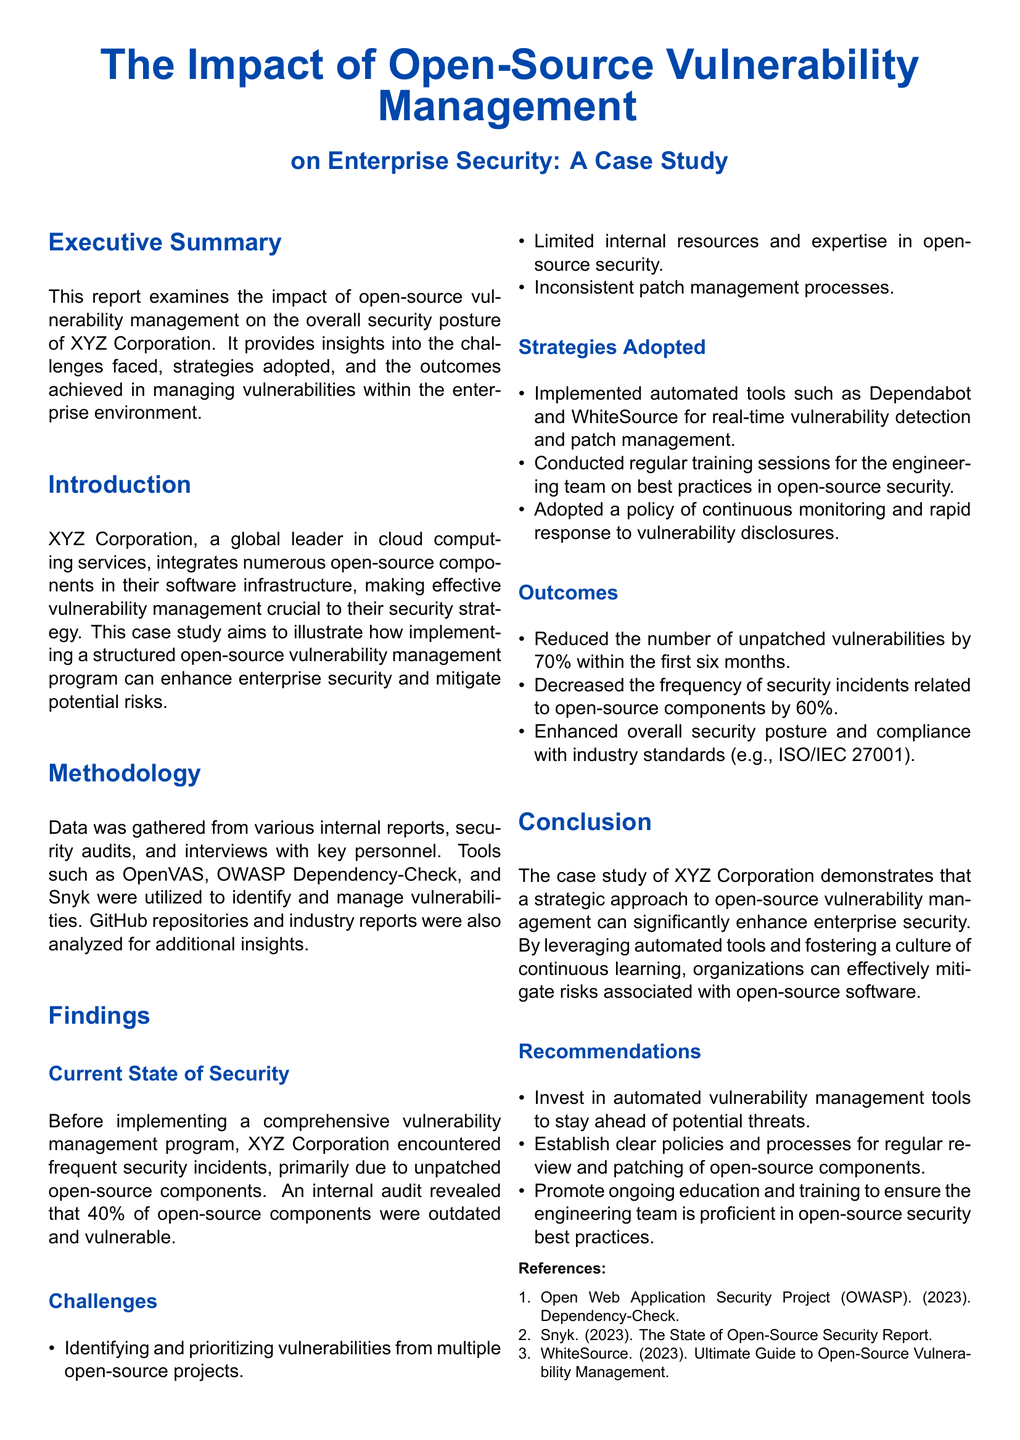What was the percentage of outdated open-source components before the program's implementation? The document states that an internal audit revealed that 40% of open-source components were outdated and vulnerable.
Answer: 40% Which tools were utilized for vulnerability management? The report mentions that OpenVAS, OWASP Dependency-Check, and Snyk were utilized for identifying and managing vulnerabilities.
Answer: OpenVAS, OWASP Dependency-Check, Snyk How much did unpatched vulnerabilities decrease within the first six months? The document indicates that the number of unpatched vulnerabilities was reduced by 70% within the first six months.
Answer: 70% What was the decrease in the frequency of security incidents related to open-source components? According to the findings, there was a decrease of 60% in the frequency of security incidents related to open-source components.
Answer: 60% What is one of the strategies adopted for managing vulnerabilities? The report notes that one of the strategies adopted was implementing automated tools such as Dependabot and WhiteSource for real-time vulnerability detection and patch management.
Answer: Implemented automated tools What is the main focus of the case study in the report? The report focuses on the impact of open-source vulnerability management on the overall security posture of XYZ Corporation.
Answer: Impact of open-source vulnerability management What industry standard does the report mention for compliance? The report mentions compliance with the industry standard ISO/IEC 27001.
Answer: ISO/IEC 27001 What is the purpose of regular training sessions mentioned in the strategies? The training sessions are conducted for the engineering team on best practices in open-source security.
Answer: Best practices in open-source security 